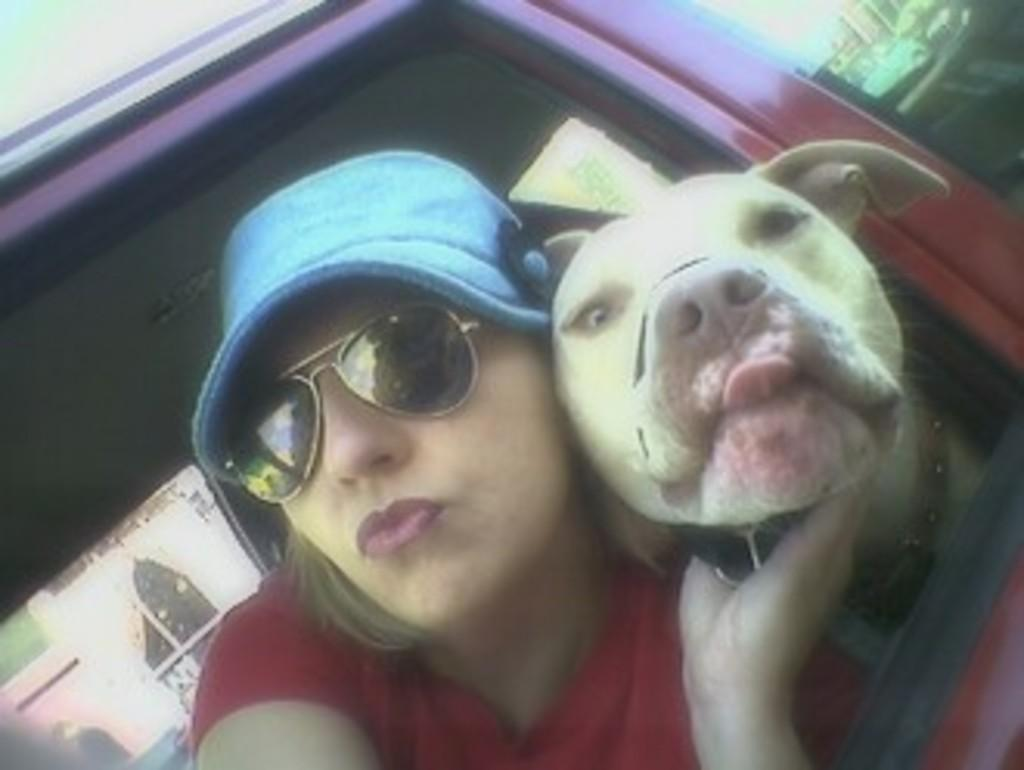Who is present in the image? There is a woman and a dog in the image. What is the woman wearing on her face? The woman is wearing blue color glasses. What color are the woman's clothes? The woman is wearing red color clothes. Can you describe the background of the image? There is a person and buildings in the background of the image. What type of juice is the dog drinking in the image? There is no juice present in the image; the dog is not depicted as drinking anything. 